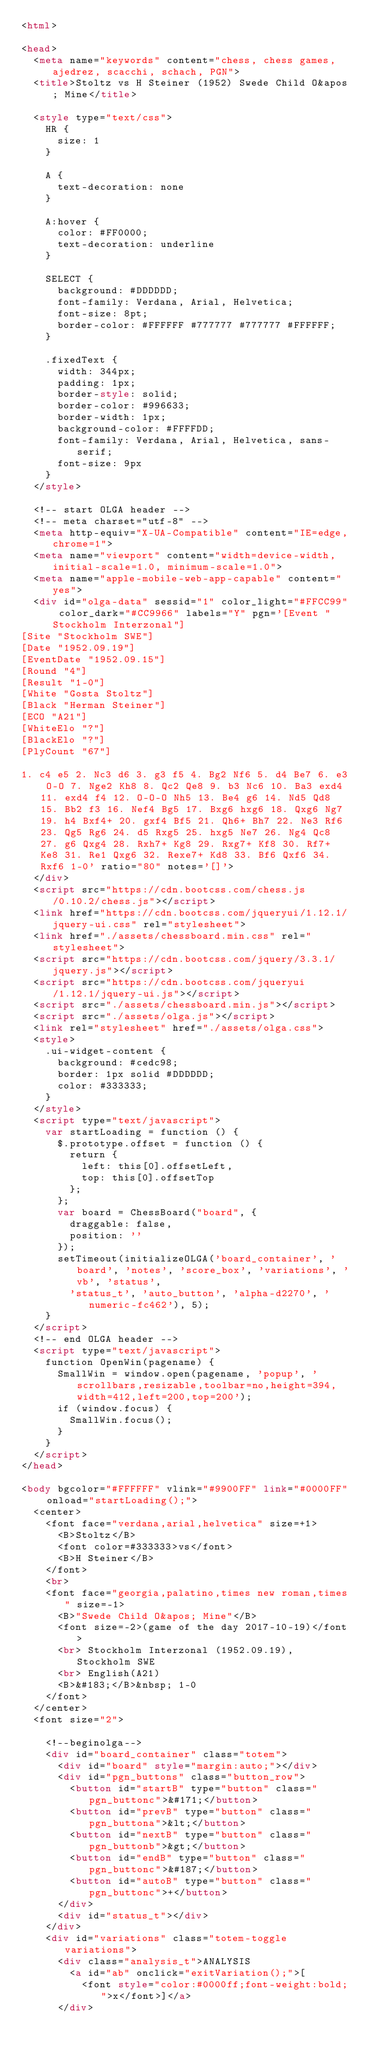Convert code to text. <code><loc_0><loc_0><loc_500><loc_500><_HTML_><html>

<head>
  <meta name="keywords" content="chess, chess games, ajedrez, scacchi, schach, PGN">
  <title>Stoltz vs H Steiner (1952) Swede Child O&apos; Mine</title>

  <style type="text/css">
    HR {
      size: 1
    }

    A {
      text-decoration: none
    }

    A:hover {
      color: #FF0000;
      text-decoration: underline
    }

    SELECT {
      background: #DDDDDD;
      font-family: Verdana, Arial, Helvetica;
      font-size: 8pt;
      border-color: #FFFFFF #777777 #777777 #FFFFFF;
    }

    .fixedText {
      width: 344px;
      padding: 1px;
      border-style: solid;
      border-color: #996633;
      border-width: 1px;
      background-color: #FFFFDD;
      font-family: Verdana, Arial, Helvetica, sans-serif;
      font-size: 9px
    }
  </style>

  <!-- start OLGA header -->
  <!-- meta charset="utf-8" -->
  <meta http-equiv="X-UA-Compatible" content="IE=edge,chrome=1">
  <meta name="viewport" content="width=device-width, initial-scale=1.0, minimum-scale=1.0">
  <meta name="apple-mobile-web-app-capable" content="yes">
  <div id="olga-data" sessid="1" color_light="#FFCC99" color_dark="#CC9966" labels="Y" pgn='[Event "Stockholm Interzonal"]
[Site "Stockholm SWE"]
[Date "1952.09.19"]
[EventDate "1952.09.15"]
[Round "4"]
[Result "1-0"]
[White "Gosta Stoltz"]
[Black "Herman Steiner"]
[ECO "A21"]
[WhiteElo "?"]
[BlackElo "?"]
[PlyCount "67"]

1. c4 e5 2. Nc3 d6 3. g3 f5 4. Bg2 Nf6 5. d4 Be7 6. e3 O-O 7. Nge2 Kh8 8. Qc2 Qe8 9. b3 Nc6 10. Ba3 exd4 11. exd4 f4 12. O-O-O Nh5 13. Be4 g6 14. Nd5 Qd8 15. Bb2 f3 16. Nef4 Bg5 17. Bxg6 hxg6 18. Qxg6 Ng7 19. h4 Bxf4+ 20. gxf4 Bf5 21. Qh6+ Bh7 22. Ne3 Rf6 23. Qg5 Rg6 24. d5 Rxg5 25. hxg5 Ne7 26. Ng4 Qc8 27. g6 Qxg4 28. Rxh7+ Kg8 29. Rxg7+ Kf8 30. Rf7+ Ke8 31. Re1 Qxg6 32. Rexe7+ Kd8 33. Bf6 Qxf6 34.Rxf6 1-0' ratio="80" notes='[]'>
  </div>
  <script src="https://cdn.bootcss.com/chess.js/0.10.2/chess.js"></script>
  <link href="https://cdn.bootcss.com/jqueryui/1.12.1/jquery-ui.css" rel="stylesheet">
  <link href="./assets/chessboard.min.css" rel="stylesheet">
  <script src="https://cdn.bootcss.com/jquery/3.3.1/jquery.js"></script>
  <script src="https://cdn.bootcss.com/jqueryui/1.12.1/jquery-ui.js"></script>
  <script src="./assets/chessboard.min.js"></script>
  <script src="./assets/olga.js"></script>
  <link rel="stylesheet" href="./assets/olga.css">
  <style>
    .ui-widget-content {
      background: #cedc98;
      border: 1px solid #DDDDDD;
      color: #333333;
    }
  </style>
  <script type="text/javascript">
    var startLoading = function () {
      $.prototype.offset = function () {
        return {
          left: this[0].offsetLeft,
          top: this[0].offsetTop
        };
      };
      var board = ChessBoard("board", {
        draggable: false,
        position: ''
      });
      setTimeout(initializeOLGA('board_container', 'board', 'notes', 'score_box', 'variations', 'vb', 'status',
        'status_t', 'auto_button', 'alpha-d2270', 'numeric-fc462'), 5);
    }
  </script>
  <!-- end OLGA header -->
  <script type="text/javascript">
    function OpenWin(pagename) {
      SmallWin = window.open(pagename, 'popup', 'scrollbars,resizable,toolbar=no,height=394,width=412,left=200,top=200');
      if (window.focus) {
        SmallWin.focus();
      }
    }
  </script>
</head>

<body bgcolor="#FFFFFF" vlink="#9900FF" link="#0000FF" onload="startLoading();">
  <center>
    <font face="verdana,arial,helvetica" size=+1>
      <B>Stoltz</B>
      <font color=#333333>vs</font>
      <B>H Steiner</B>
    </font>
    <br>
    <font face="georgia,palatino,times new roman,times" size=-1>
      <B>"Swede Child O&apos; Mine"</B>
      <font size=-2>(game of the day 2017-10-19)</font>
      <br> Stockholm Interzonal (1952.09.19), Stockholm SWE
      <br> English(A21)
      <B>&#183;</B>&nbsp; 1-0
    </font>
  </center>
  <font size="2">

    <!--beginolga-->
    <div id="board_container" class="totem">
      <div id="board" style="margin:auto;"></div>
      <div id="pgn_buttons" class="button_row">
        <button id="startB" type="button" class="pgn_buttonc">&#171;</button>
        <button id="prevB" type="button" class="pgn_buttona">&lt;</button>
        <button id="nextB" type="button" class="pgn_buttonb">&gt;</button>
        <button id="endB" type="button" class="pgn_buttonc">&#187;</button>
        <button id="autoB" type="button" class="pgn_buttonc">+</button>
      </div>
      <div id="status_t"></div>
    </div>
    <div id="variations" class="totem-toggle variations">
      <div class="analysis_t">ANALYSIS
        <a id="ab" onclick="exitVariation();">[
          <font style="color:#0000ff;font-weight:bold;">x</font>]</a>
      </div></code> 